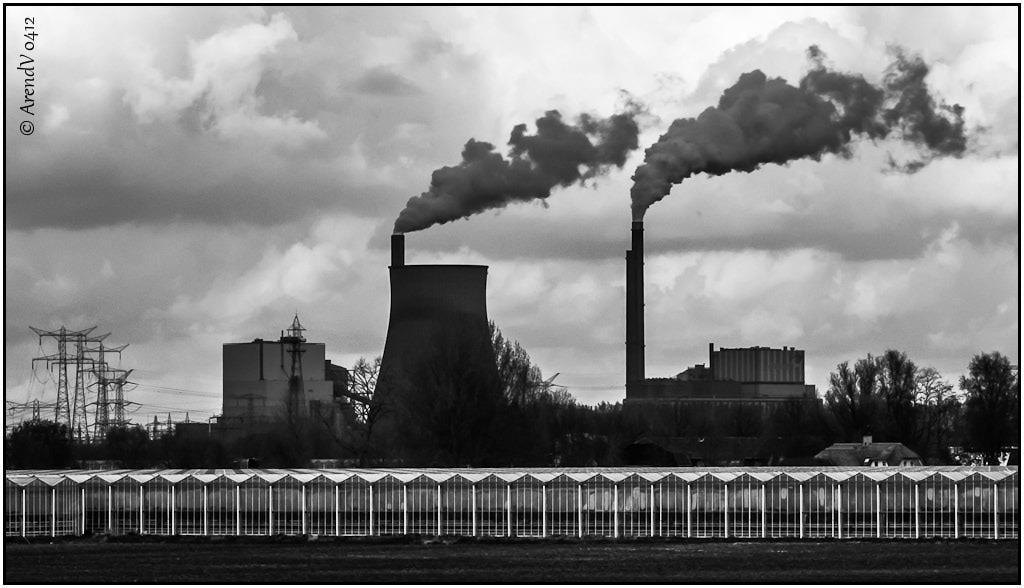What type of structures are present in the image? There are towers, buildings, and factory pipes in the image. What natural elements can be seen in the image? There are trees in the image. What man-made elements are present in the image? There are wires and a railing in the image. What is the color scheme of the image? The image is in black and white. What can be seen in the sky in the image? There is smoke in the image. Where is the jewel located in the image? There is no jewel present in the image. What direction is the front of the building facing in the image? The image is in black and white, and there is no indication of the direction the building is facing. 